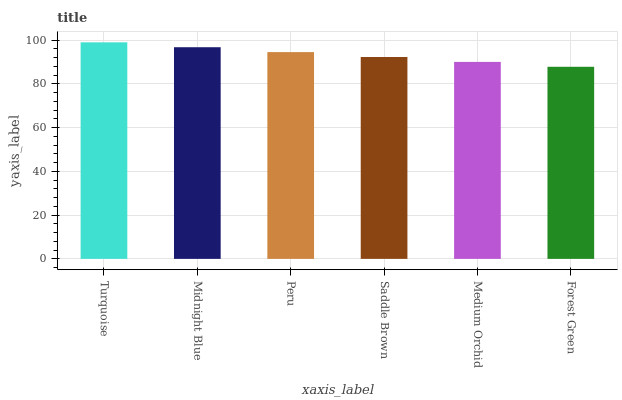Is Forest Green the minimum?
Answer yes or no. Yes. Is Turquoise the maximum?
Answer yes or no. Yes. Is Midnight Blue the minimum?
Answer yes or no. No. Is Midnight Blue the maximum?
Answer yes or no. No. Is Turquoise greater than Midnight Blue?
Answer yes or no. Yes. Is Midnight Blue less than Turquoise?
Answer yes or no. Yes. Is Midnight Blue greater than Turquoise?
Answer yes or no. No. Is Turquoise less than Midnight Blue?
Answer yes or no. No. Is Peru the high median?
Answer yes or no. Yes. Is Saddle Brown the low median?
Answer yes or no. Yes. Is Saddle Brown the high median?
Answer yes or no. No. Is Peru the low median?
Answer yes or no. No. 